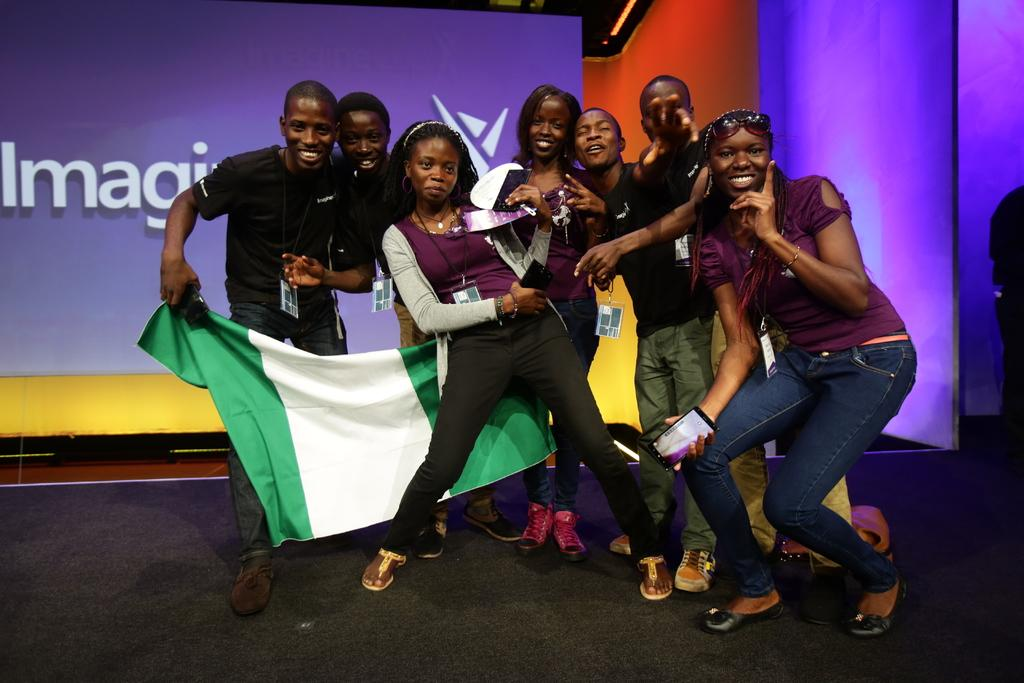What are the people in the image doing? The people in the image are standing in the middle of the image and smiling. What are the people holding in their hands? The people are holding something in their hands, but the specific object is not mentioned in the facts. What can be seen in the background of the image? There is a wall and a screen in the background of the image. What type of fuel is being used by the hen in the image? There is no hen present in the image, so it is not possible to determine what type of fuel it might be using. 